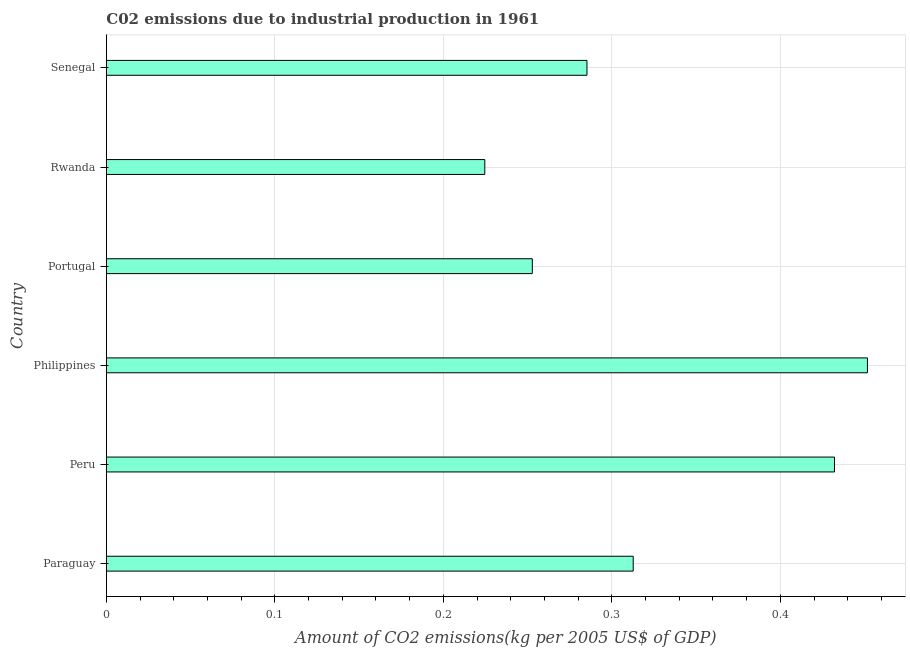Does the graph contain grids?
Give a very brief answer. Yes. What is the title of the graph?
Your answer should be very brief. C02 emissions due to industrial production in 1961. What is the label or title of the X-axis?
Offer a terse response. Amount of CO2 emissions(kg per 2005 US$ of GDP). What is the label or title of the Y-axis?
Give a very brief answer. Country. What is the amount of co2 emissions in Philippines?
Provide a succinct answer. 0.45. Across all countries, what is the maximum amount of co2 emissions?
Your answer should be compact. 0.45. Across all countries, what is the minimum amount of co2 emissions?
Provide a short and direct response. 0.22. In which country was the amount of co2 emissions minimum?
Your answer should be compact. Rwanda. What is the sum of the amount of co2 emissions?
Provide a short and direct response. 1.96. What is the difference between the amount of co2 emissions in Paraguay and Rwanda?
Give a very brief answer. 0.09. What is the average amount of co2 emissions per country?
Provide a short and direct response. 0.33. What is the median amount of co2 emissions?
Provide a succinct answer. 0.3. In how many countries, is the amount of co2 emissions greater than 0.32 kg per 2005 US$ of GDP?
Your response must be concise. 2. What is the ratio of the amount of co2 emissions in Paraguay to that in Rwanda?
Your response must be concise. 1.39. What is the difference between the highest and the lowest amount of co2 emissions?
Keep it short and to the point. 0.23. In how many countries, is the amount of co2 emissions greater than the average amount of co2 emissions taken over all countries?
Keep it short and to the point. 2. Are the values on the major ticks of X-axis written in scientific E-notation?
Give a very brief answer. No. What is the Amount of CO2 emissions(kg per 2005 US$ of GDP) of Paraguay?
Your response must be concise. 0.31. What is the Amount of CO2 emissions(kg per 2005 US$ of GDP) in Peru?
Your answer should be very brief. 0.43. What is the Amount of CO2 emissions(kg per 2005 US$ of GDP) in Philippines?
Make the answer very short. 0.45. What is the Amount of CO2 emissions(kg per 2005 US$ of GDP) of Portugal?
Provide a short and direct response. 0.25. What is the Amount of CO2 emissions(kg per 2005 US$ of GDP) in Rwanda?
Keep it short and to the point. 0.22. What is the Amount of CO2 emissions(kg per 2005 US$ of GDP) of Senegal?
Offer a terse response. 0.29. What is the difference between the Amount of CO2 emissions(kg per 2005 US$ of GDP) in Paraguay and Peru?
Give a very brief answer. -0.12. What is the difference between the Amount of CO2 emissions(kg per 2005 US$ of GDP) in Paraguay and Philippines?
Ensure brevity in your answer.  -0.14. What is the difference between the Amount of CO2 emissions(kg per 2005 US$ of GDP) in Paraguay and Portugal?
Provide a succinct answer. 0.06. What is the difference between the Amount of CO2 emissions(kg per 2005 US$ of GDP) in Paraguay and Rwanda?
Provide a succinct answer. 0.09. What is the difference between the Amount of CO2 emissions(kg per 2005 US$ of GDP) in Paraguay and Senegal?
Make the answer very short. 0.03. What is the difference between the Amount of CO2 emissions(kg per 2005 US$ of GDP) in Peru and Philippines?
Your answer should be compact. -0.02. What is the difference between the Amount of CO2 emissions(kg per 2005 US$ of GDP) in Peru and Portugal?
Offer a terse response. 0.18. What is the difference between the Amount of CO2 emissions(kg per 2005 US$ of GDP) in Peru and Rwanda?
Your response must be concise. 0.21. What is the difference between the Amount of CO2 emissions(kg per 2005 US$ of GDP) in Peru and Senegal?
Make the answer very short. 0.15. What is the difference between the Amount of CO2 emissions(kg per 2005 US$ of GDP) in Philippines and Portugal?
Offer a terse response. 0.2. What is the difference between the Amount of CO2 emissions(kg per 2005 US$ of GDP) in Philippines and Rwanda?
Offer a very short reply. 0.23. What is the difference between the Amount of CO2 emissions(kg per 2005 US$ of GDP) in Philippines and Senegal?
Make the answer very short. 0.17. What is the difference between the Amount of CO2 emissions(kg per 2005 US$ of GDP) in Portugal and Rwanda?
Provide a short and direct response. 0.03. What is the difference between the Amount of CO2 emissions(kg per 2005 US$ of GDP) in Portugal and Senegal?
Give a very brief answer. -0.03. What is the difference between the Amount of CO2 emissions(kg per 2005 US$ of GDP) in Rwanda and Senegal?
Offer a very short reply. -0.06. What is the ratio of the Amount of CO2 emissions(kg per 2005 US$ of GDP) in Paraguay to that in Peru?
Keep it short and to the point. 0.72. What is the ratio of the Amount of CO2 emissions(kg per 2005 US$ of GDP) in Paraguay to that in Philippines?
Ensure brevity in your answer.  0.69. What is the ratio of the Amount of CO2 emissions(kg per 2005 US$ of GDP) in Paraguay to that in Portugal?
Your response must be concise. 1.24. What is the ratio of the Amount of CO2 emissions(kg per 2005 US$ of GDP) in Paraguay to that in Rwanda?
Offer a terse response. 1.39. What is the ratio of the Amount of CO2 emissions(kg per 2005 US$ of GDP) in Paraguay to that in Senegal?
Provide a short and direct response. 1.1. What is the ratio of the Amount of CO2 emissions(kg per 2005 US$ of GDP) in Peru to that in Portugal?
Your answer should be very brief. 1.71. What is the ratio of the Amount of CO2 emissions(kg per 2005 US$ of GDP) in Peru to that in Rwanda?
Provide a succinct answer. 1.92. What is the ratio of the Amount of CO2 emissions(kg per 2005 US$ of GDP) in Peru to that in Senegal?
Make the answer very short. 1.51. What is the ratio of the Amount of CO2 emissions(kg per 2005 US$ of GDP) in Philippines to that in Portugal?
Make the answer very short. 1.79. What is the ratio of the Amount of CO2 emissions(kg per 2005 US$ of GDP) in Philippines to that in Rwanda?
Make the answer very short. 2.01. What is the ratio of the Amount of CO2 emissions(kg per 2005 US$ of GDP) in Philippines to that in Senegal?
Keep it short and to the point. 1.58. What is the ratio of the Amount of CO2 emissions(kg per 2005 US$ of GDP) in Portugal to that in Rwanda?
Give a very brief answer. 1.13. What is the ratio of the Amount of CO2 emissions(kg per 2005 US$ of GDP) in Portugal to that in Senegal?
Provide a short and direct response. 0.89. What is the ratio of the Amount of CO2 emissions(kg per 2005 US$ of GDP) in Rwanda to that in Senegal?
Offer a very short reply. 0.79. 